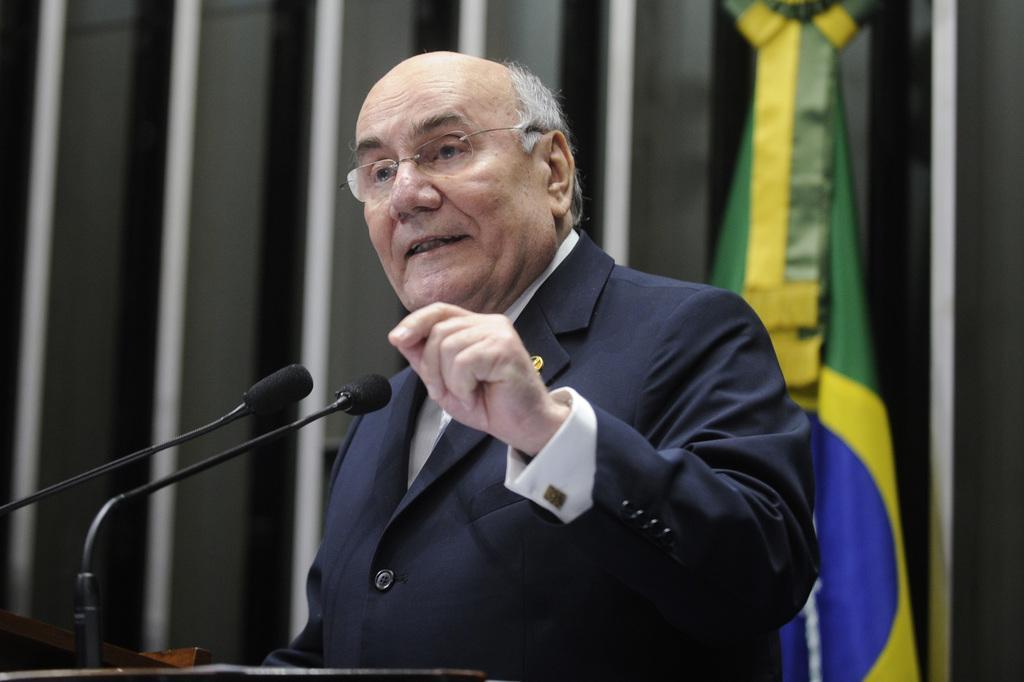Please provide a concise description of this image. In the picture there is a man,he is standing in front of the table and speaking something,there are two mics in front of the man. Behind the man there is a flag. 